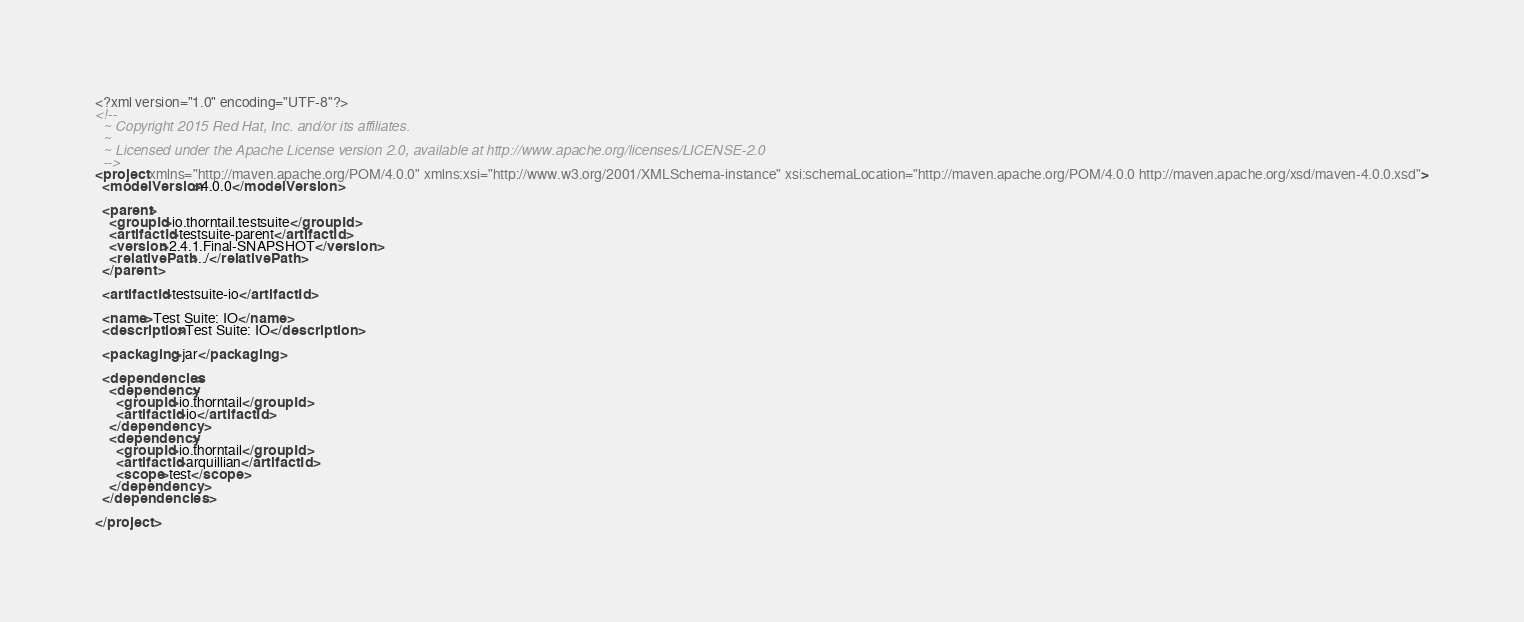<code> <loc_0><loc_0><loc_500><loc_500><_XML_><?xml version="1.0" encoding="UTF-8"?>
<!--
  ~ Copyright 2015 Red Hat, Inc. and/or its affiliates.
  ~
  ~ Licensed under the Apache License version 2.0, available at http://www.apache.org/licenses/LICENSE-2.0
  -->
<project xmlns="http://maven.apache.org/POM/4.0.0" xmlns:xsi="http://www.w3.org/2001/XMLSchema-instance" xsi:schemaLocation="http://maven.apache.org/POM/4.0.0 http://maven.apache.org/xsd/maven-4.0.0.xsd">
  <modelVersion>4.0.0</modelVersion>

  <parent>
    <groupId>io.thorntail.testsuite</groupId>
    <artifactId>testsuite-parent</artifactId>
    <version>2.4.1.Final-SNAPSHOT</version>
    <relativePath>../</relativePath>
  </parent>

  <artifactId>testsuite-io</artifactId>

  <name>Test Suite: IO</name>
  <description>Test Suite: IO</description>

  <packaging>jar</packaging>

  <dependencies>
    <dependency>
      <groupId>io.thorntail</groupId>
      <artifactId>io</artifactId>
    </dependency>
    <dependency>
      <groupId>io.thorntail</groupId>
      <artifactId>arquillian</artifactId>
      <scope>test</scope>
    </dependency>
  </dependencies>

</project>
</code> 